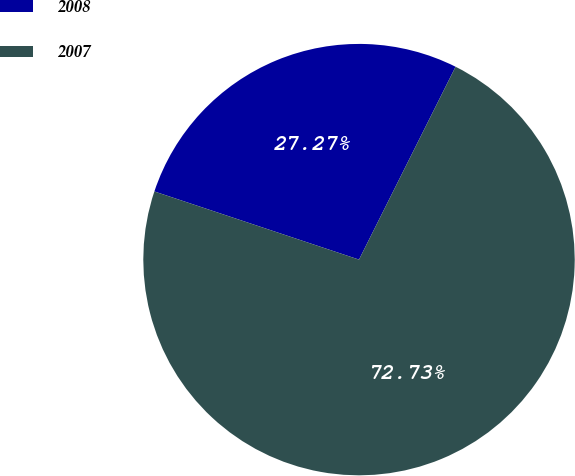<chart> <loc_0><loc_0><loc_500><loc_500><pie_chart><fcel>2008<fcel>2007<nl><fcel>27.27%<fcel>72.73%<nl></chart> 